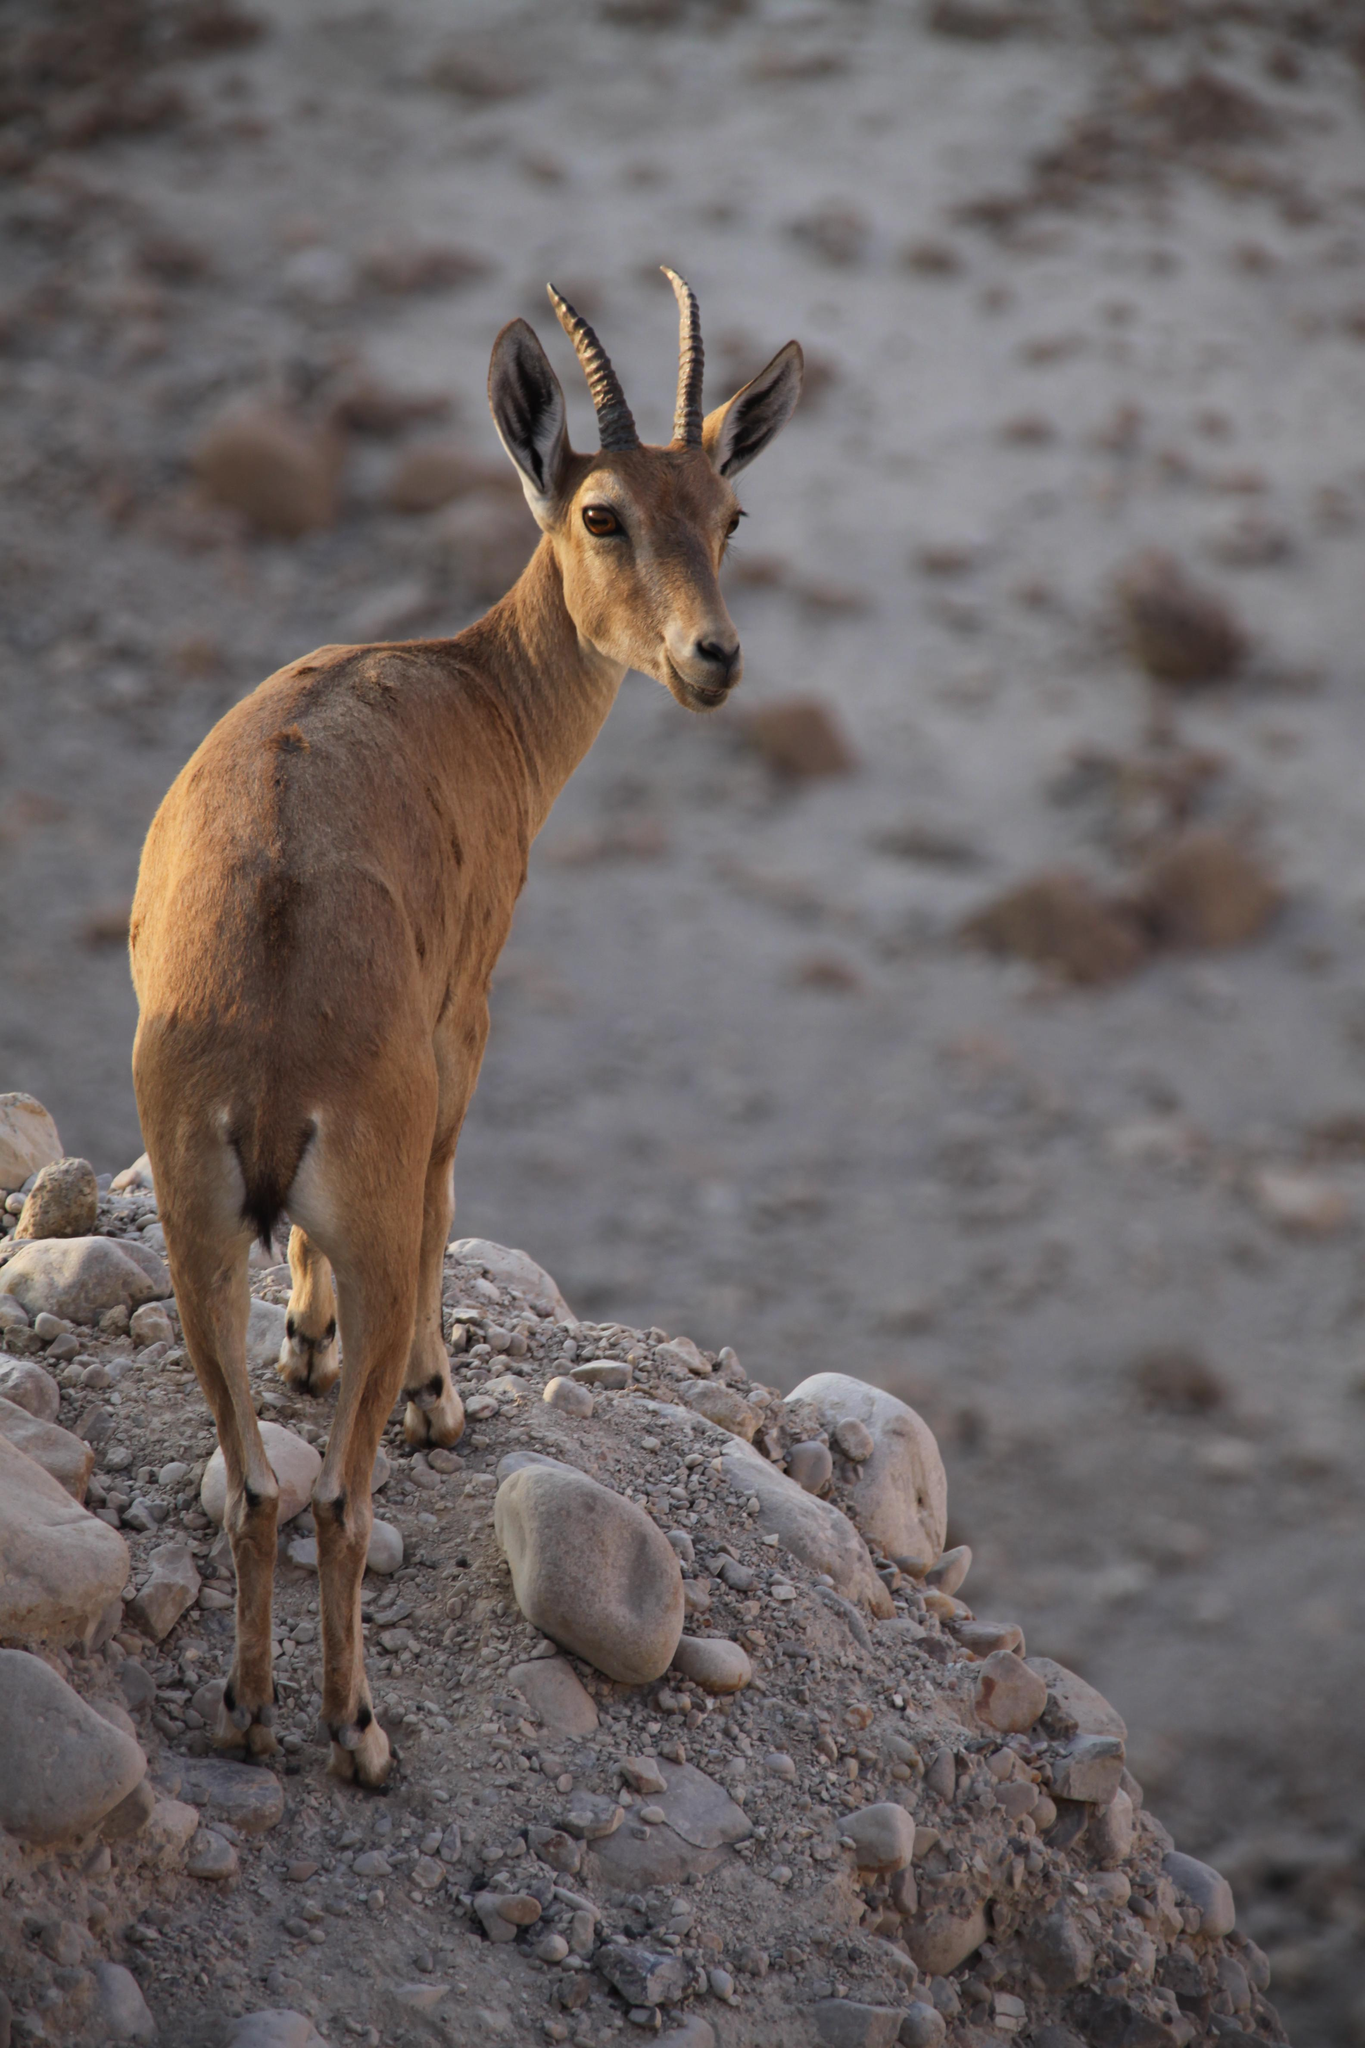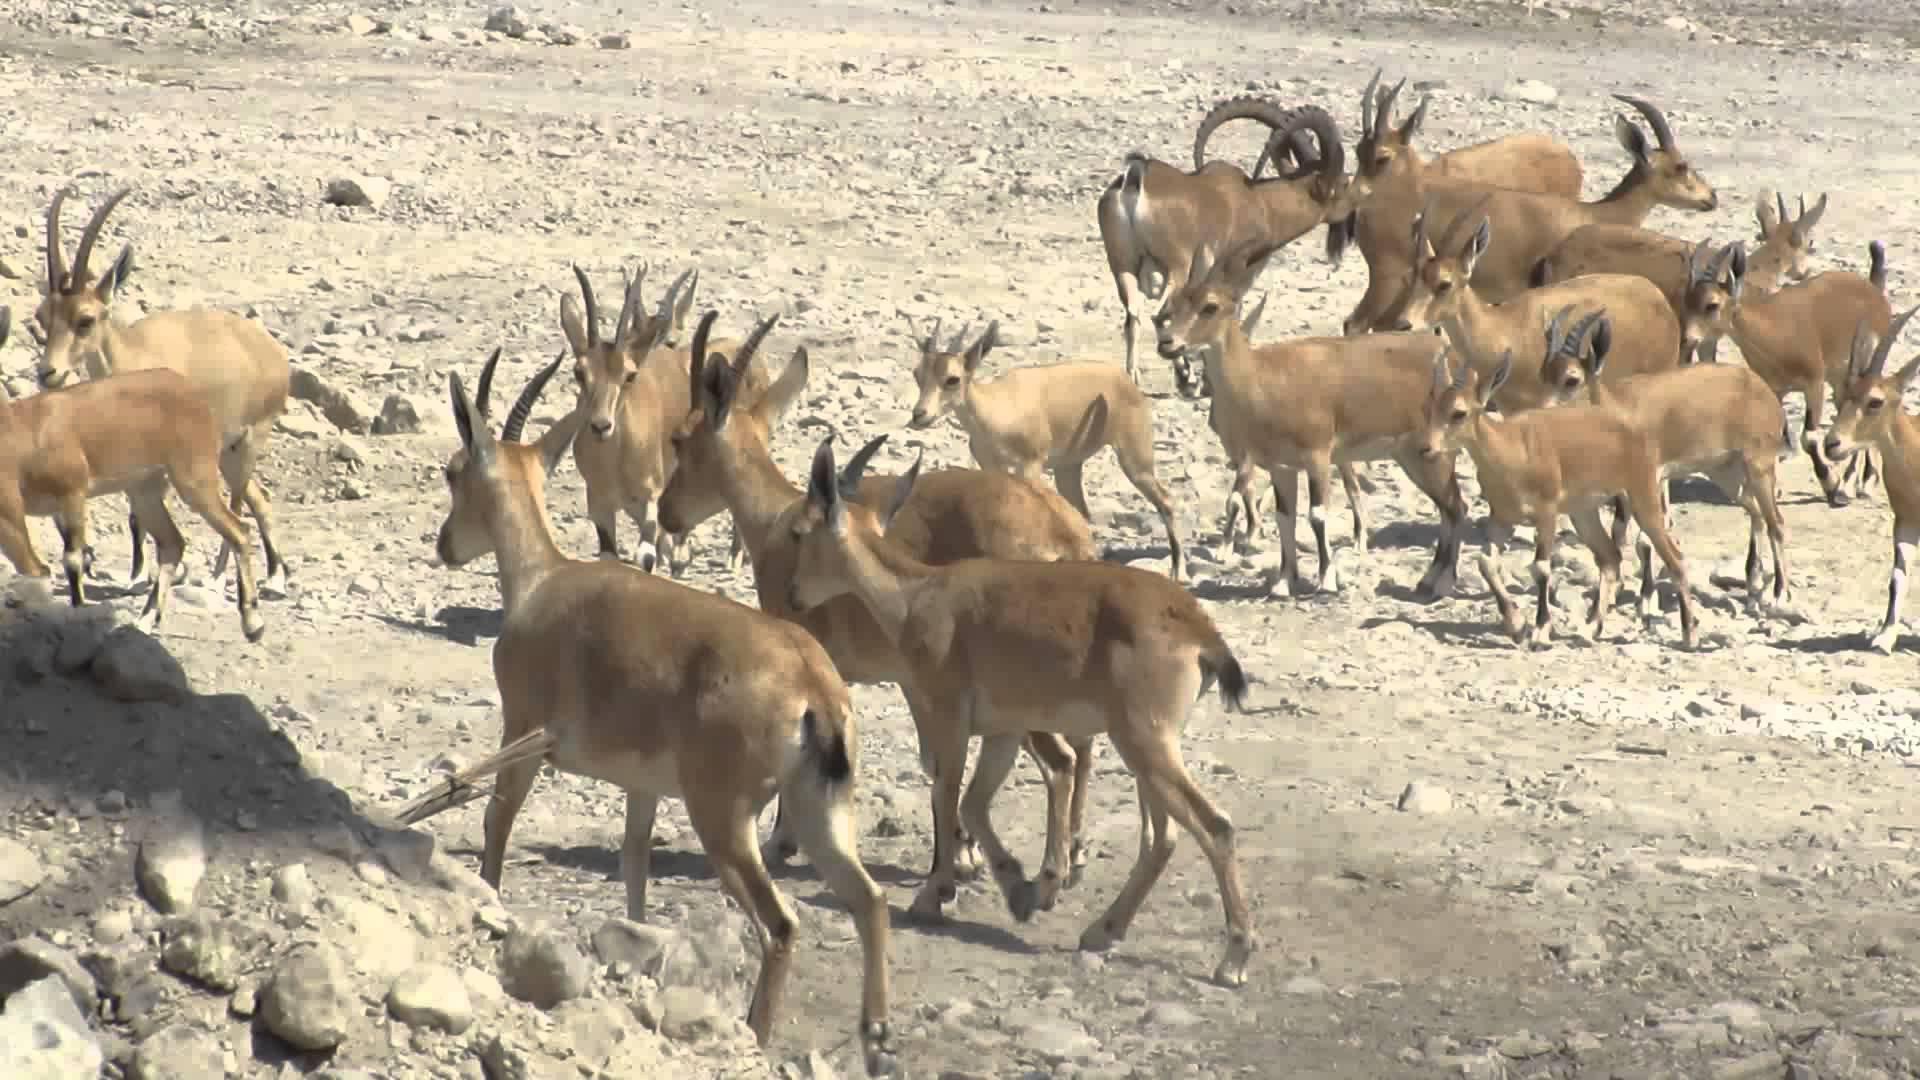The first image is the image on the left, the second image is the image on the right. For the images displayed, is the sentence "At least one big horn sheep is looking down over the edge of a tall cliff." factually correct? Answer yes or no. No. 